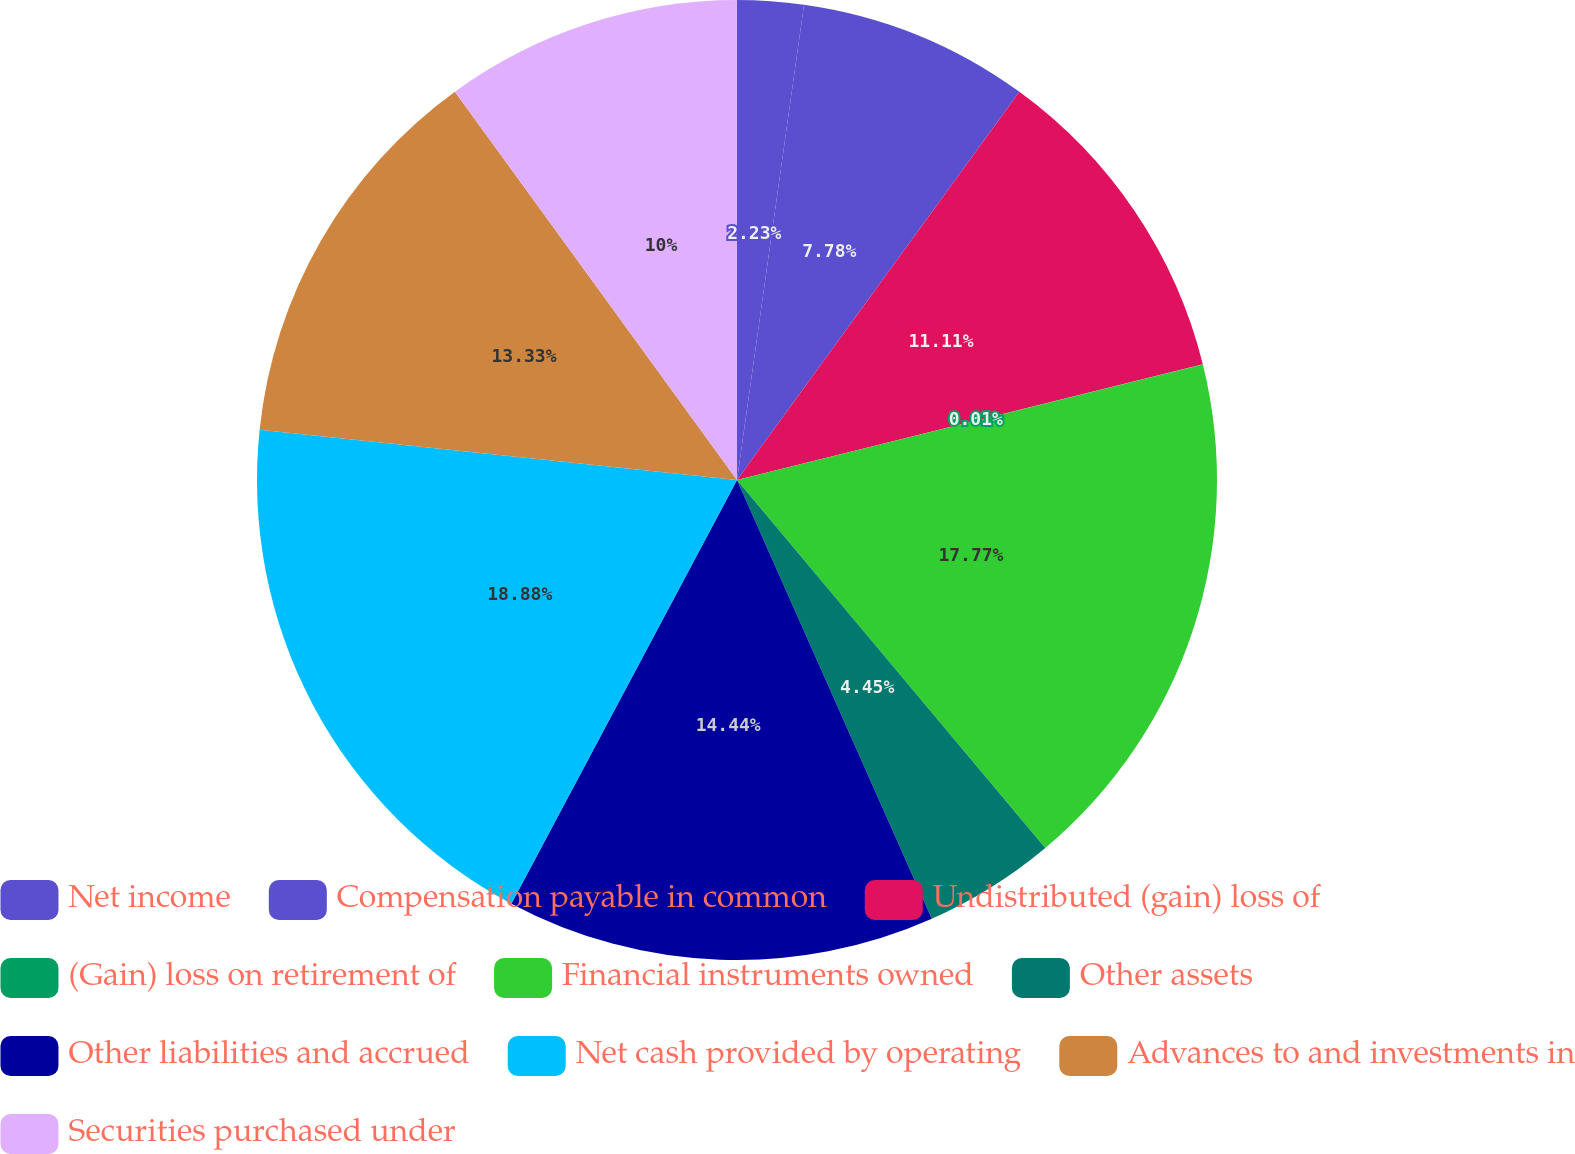Convert chart to OTSL. <chart><loc_0><loc_0><loc_500><loc_500><pie_chart><fcel>Net income<fcel>Compensation payable in common<fcel>Undistributed (gain) loss of<fcel>(Gain) loss on retirement of<fcel>Financial instruments owned<fcel>Other assets<fcel>Other liabilities and accrued<fcel>Net cash provided by operating<fcel>Advances to and investments in<fcel>Securities purchased under<nl><fcel>2.23%<fcel>7.78%<fcel>11.11%<fcel>0.01%<fcel>17.77%<fcel>4.45%<fcel>14.44%<fcel>18.88%<fcel>13.33%<fcel>10.0%<nl></chart> 